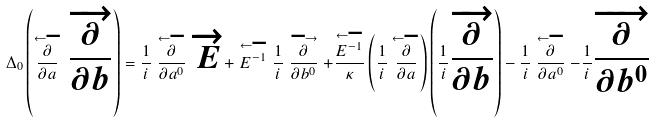Convert formula to latex. <formula><loc_0><loc_0><loc_500><loc_500>\Delta _ { 0 } \left ( \stackrel { \longleftarrow } { \frac { \partial } { \partial a } } \, \overrightarrow { \frac { \partial } { \partial b } } \right ) = \frac { 1 } { i } \stackrel { \longleftarrow } { \frac { \partial } { \partial a ^ { 0 } } } \, \overrightarrow { E } + \stackrel { \longleftarrow } { E ^ { - 1 } } \frac { 1 } { i } \stackrel { \longrightarrow } { \frac { \partial } { \partial b ^ { 0 } } } + \frac { \stackrel { \longleftarrow } { E ^ { - 1 } } } { \kappa } \left ( \frac { 1 } { i } \stackrel { \longleftarrow } { \frac { \partial } { \partial a } } \right ) \left ( \frac { 1 } { i } \overrightarrow { \frac { \partial } { \partial b } } \right ) - \frac { 1 } { i } \stackrel { \longleftarrow } { \frac { \partial } { \partial a ^ { 0 } } } - \frac { 1 } { i } \overrightarrow { \frac { \partial } { \partial b ^ { 0 } } }</formula> 